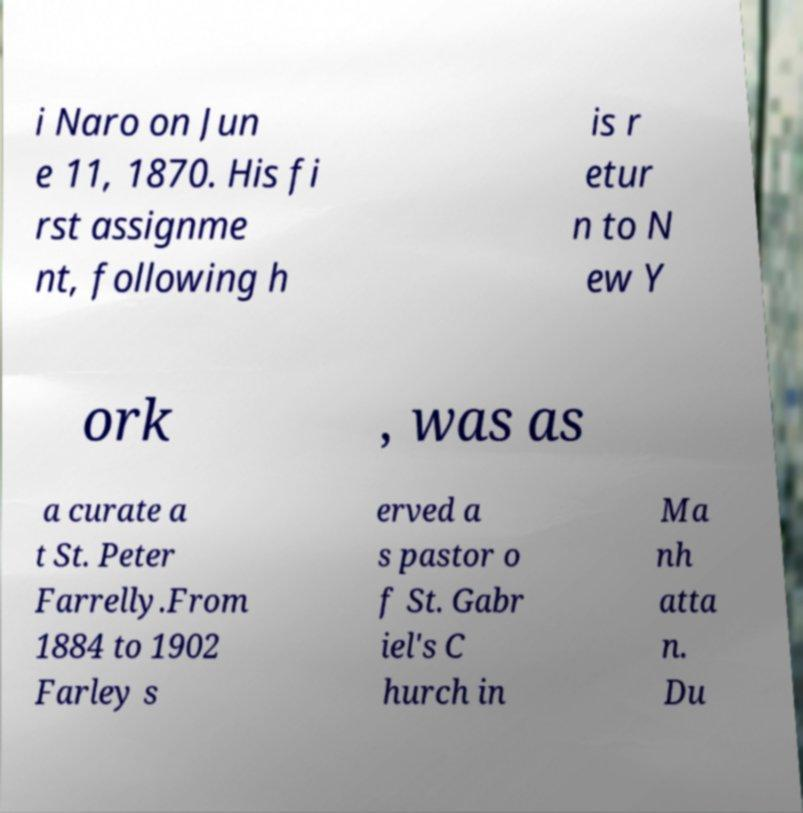For documentation purposes, I need the text within this image transcribed. Could you provide that? i Naro on Jun e 11, 1870. His fi rst assignme nt, following h is r etur n to N ew Y ork , was as a curate a t St. Peter Farrelly.From 1884 to 1902 Farley s erved a s pastor o f St. Gabr iel's C hurch in Ma nh atta n. Du 